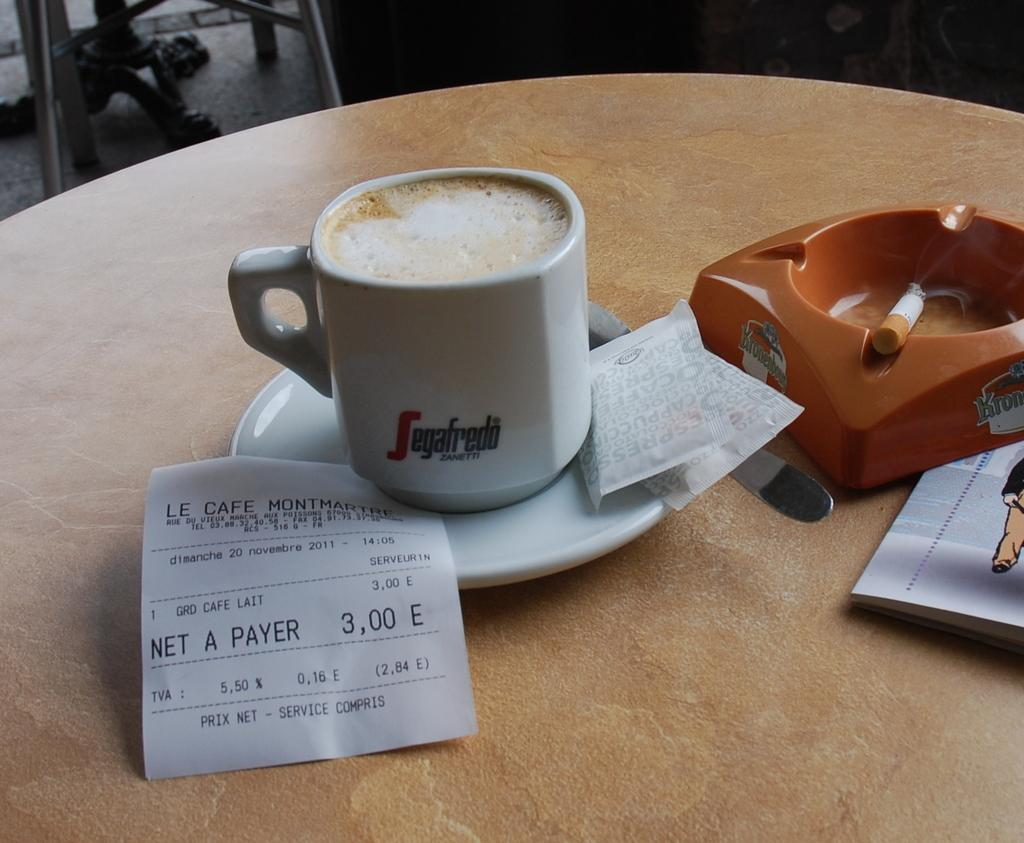<image>
Present a compact description of the photo's key features. a full coffee mug sittingh next to an ash tray with a reciebet to le cafe under it. 